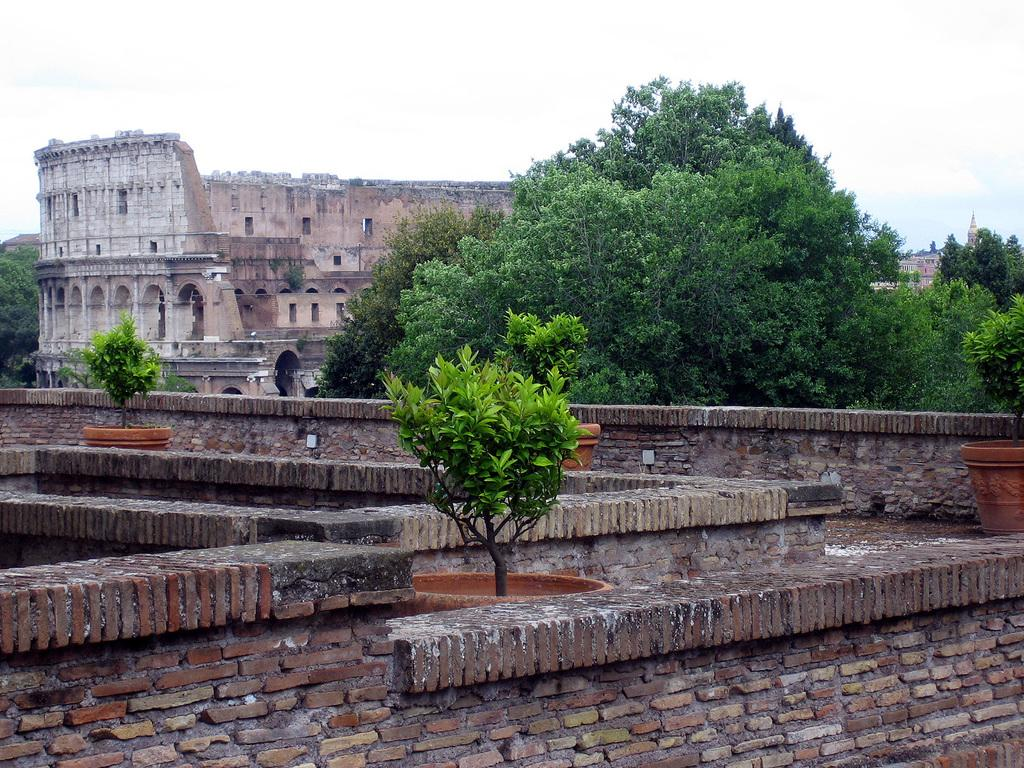What type of structure is visible in the image? There is a brick wall in the image. What other natural elements can be seen in the image? There are plants, trees, and the sky visible in the image. What objects are present that might be used for gardening? There are pots in the image. What type of man-made structures are visible in the image? There are buildings in the image. How does the brick wall express its disgust in the image? The brick wall does not express any emotions, including disgust, as it is an inanimate object. What type of fiction is being read by the clover in the image? There is no clover present in the image, and therefore no reading activity can be observed. 